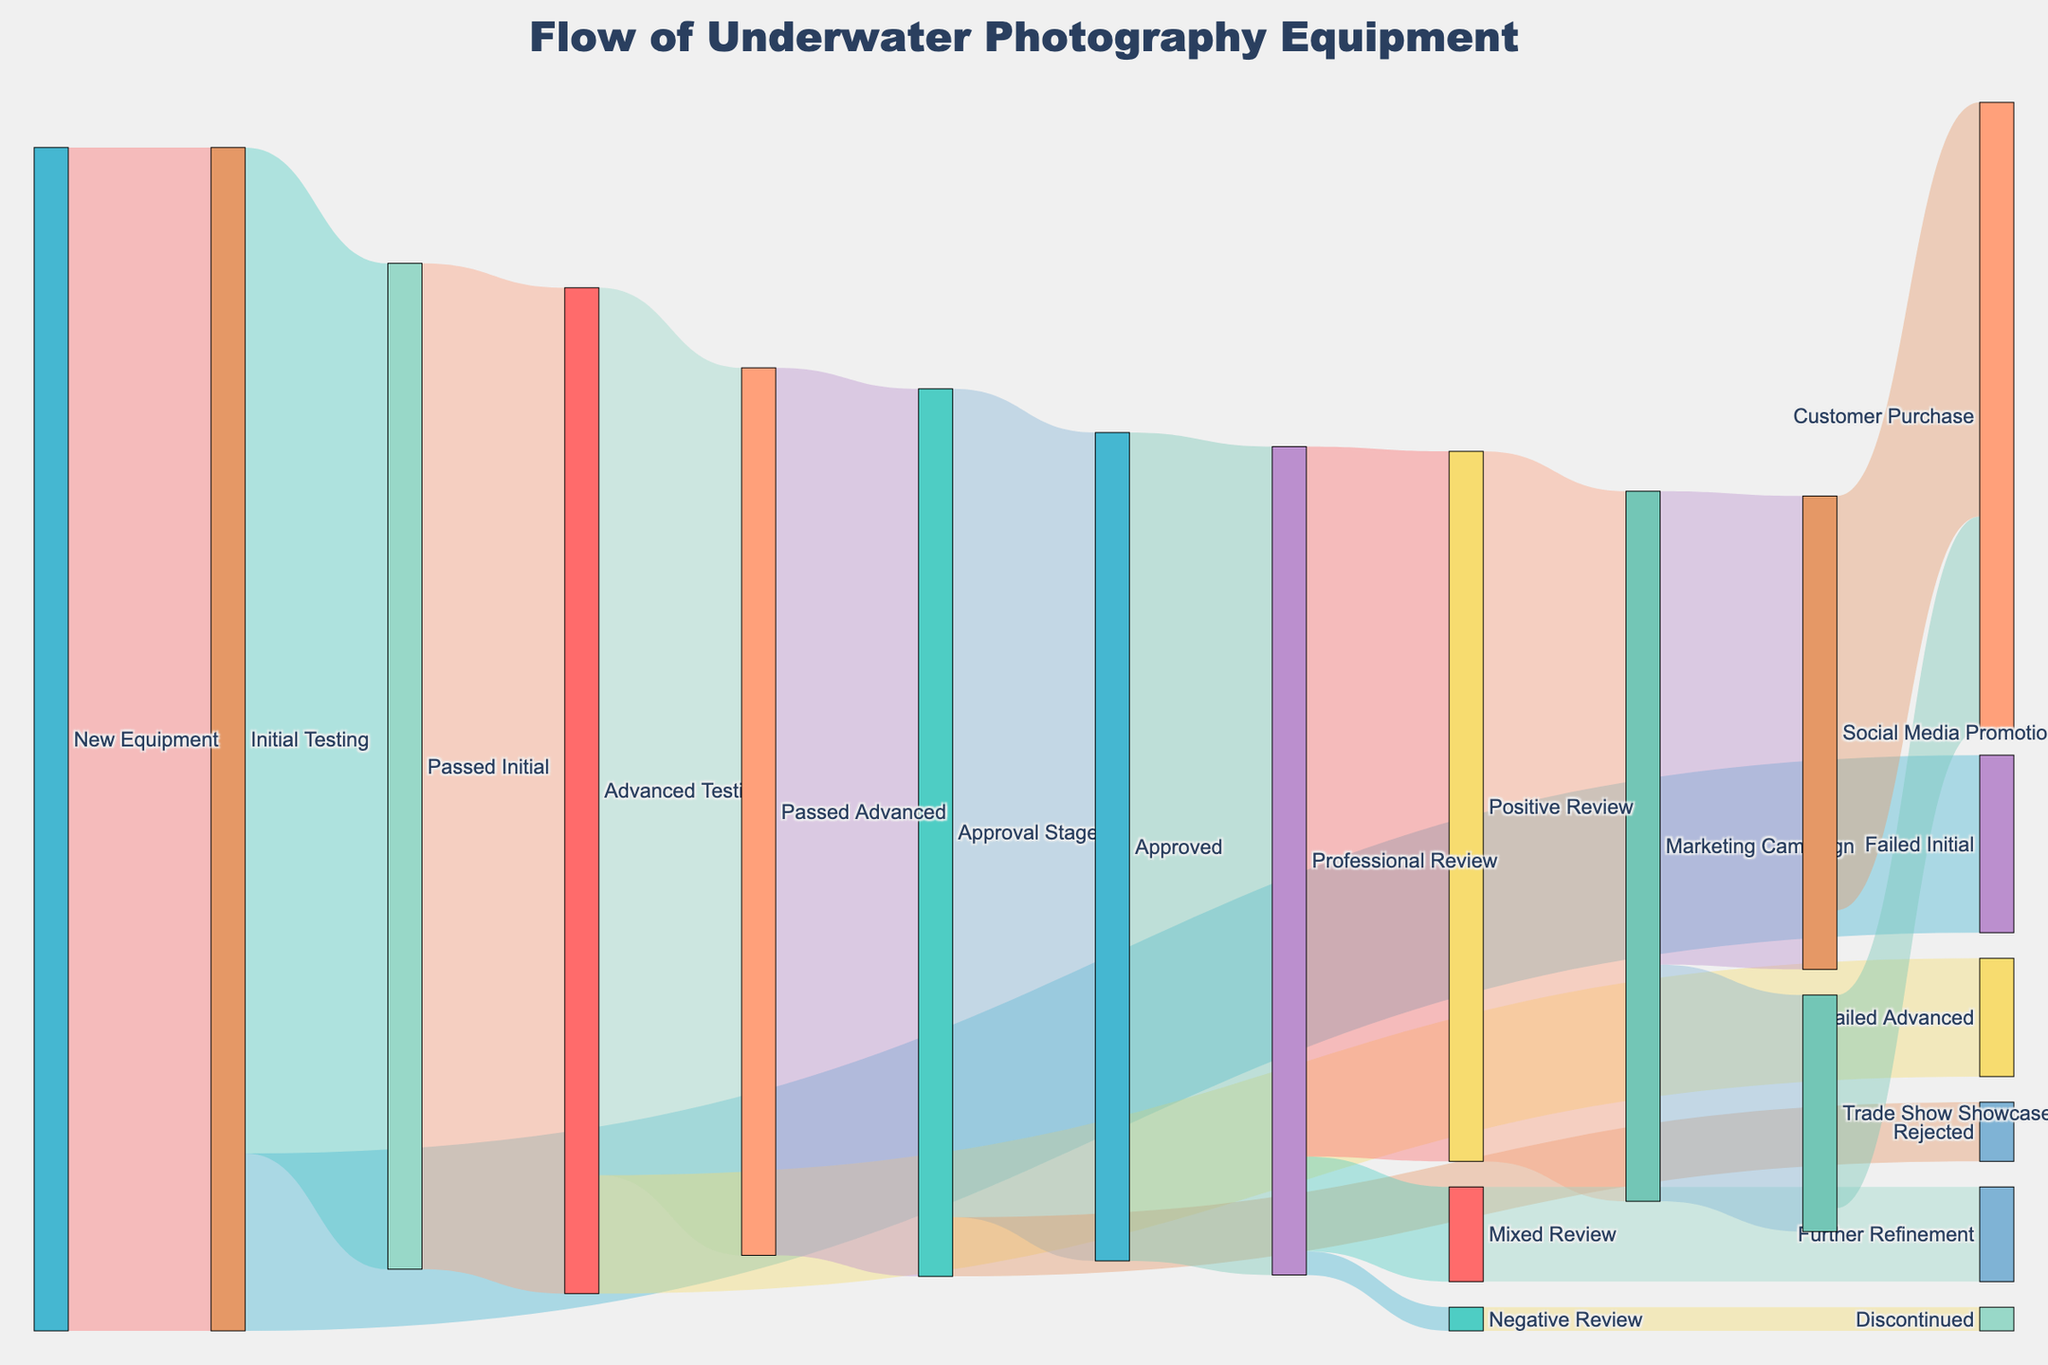What is the total number of new equipment initially tested? All new equipment flows into the "Initial Testing" stage, which equals 100 units as indicated by the value beside the line from "New Equipment" to "Initial Testing".
Answer: 100 How many equipment units passed the initial testing? Refer to the flow lines from "Initial Testing" to "Passed Initial". The figure next to this connection shows that 85 units passed the initial testing.
Answer: 85 What percentage of the initially tested equipment failed the initial testing? From "Initial Testing", 15 units failed as shown by the line to "Failed Initial". The percentage is calculated by (15 / 100) * 100% = 15%.
Answer: 15% How many units progressed to the Approval Stage after passing advanced testing? Follow the line from "Passed Advanced" to "Approval Stage", which shows the transition of 75 units.
Answer: 75 What is the total number of equipment approved from the Approval Stage? Look at the flow from "Approval Stage" to "Approved"; the value is 70 units.
Answer: 70 How many units received a positive review at the professional review stage? Refer to the flow from "Professional Review" to "Positive Review", indicating 60 units received positive reviews.
Answer: 60 Compare the number of units that went to Social Media Promotion versus Trade Show Showcase after the marketing campaign. From "Marketing Campaign," 40 units went to "Social Media Promotion" and 20 units to "Trade Show Showcase". Comparing these, Social Media Promotion received more units.
Answer: Social Media Promotion How many units were ultimately purchased by customers after promotions? Sum the units from "Social Media Promotion" to "Customer Purchase" (35) and "Trade Show Showcase" to "Customer Purchase" (18), resulting in a total of 35 + 18 = 53 units.
Answer: 53 Which stage had the highest dropout rate, and what was the value? Compare the dropout values: "Initial Testing" to "Failed Initial" (15), "Advanced Testing" to "Failed Advanced" (10), and "Approval Stage" to "Rejected" (5). The highest dropout rate happened at the "Initial Testing" stage with 15 units.
Answer: Initial Testing, 15 How many units went to further refinement after receiving mixed reviews? Follow the flow from "Mixed Review" to "Further Refinement," which shows 8 units.
Answer: 8 